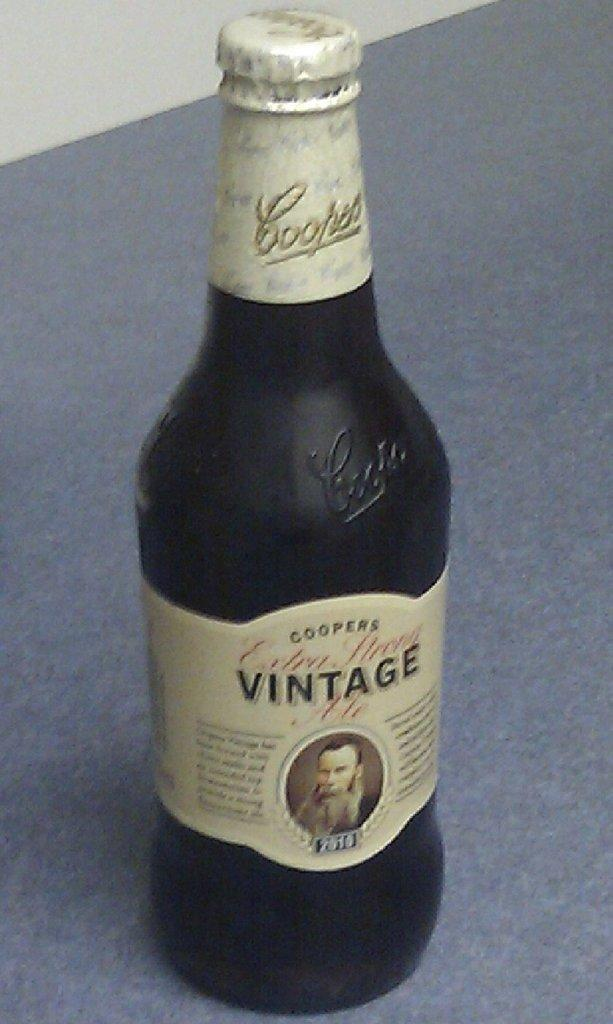<image>
Offer a succinct explanation of the picture presented. Alcohol bottle with a label that says "VINTAGE" on it. 